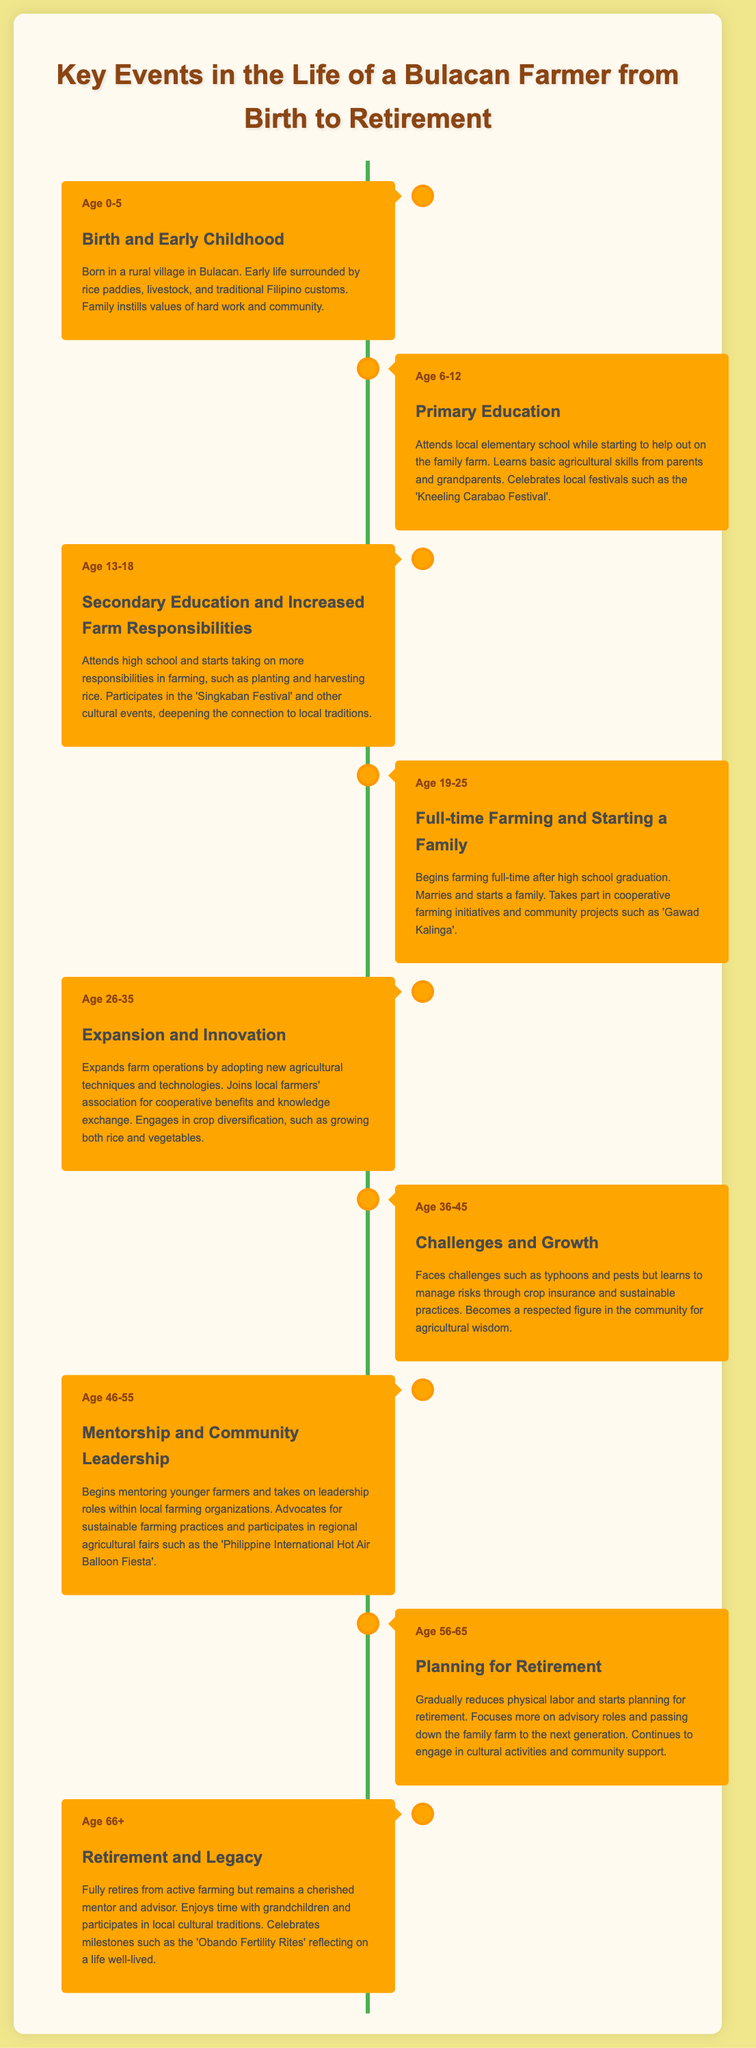What is the age range for Birth and Early Childhood? The event covers the stage of life from age 0 to 5 years.
Answer: Age 0-5 What festival is celebrated during Primary Education? The event mentions a local festival celebrated during primary education.
Answer: Kneeling Carabao Festival What significant life event occurs between ages 19 to 25? This age range marks the transition to full-time farming and starting a family.
Answer: Marries and starts a family At what age does the farmer begin mentorship? The event about mentorship occurs when the farmer is between 46 to 55 years old.
Answer: Age 46-55 What term refers to the practices advocated by the farmer in later years? The farmer advocates for sustainable farming practices as he mentors younger farmers.
Answer: Sustainable farming practices Which agricultural organization does the farmer join at age 26-35? At this stage, the farmer joins a local farmers' association.
Answer: Local farmers' association What is a key challenge faced between ages 36 to 45? The event discusses facing challenges from natural disasters such as typhoons.
Answer: Typhoons What is the final event listed in the timeline? The last event discusses the retirement phase of the farmer's life.
Answer: Retirement and Legacy How is the farmer's role in the community characterized as he ages? As the farmer ages, he becomes a respected mentor and advisor.
Answer: Respected mentor and advisor 